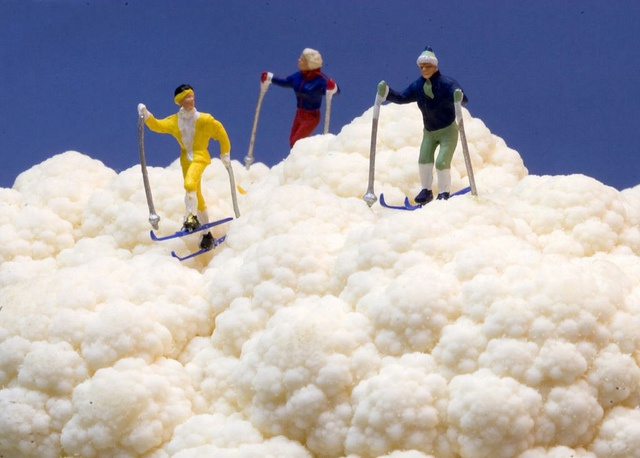Describe the objects in this image and their specific colors. I can see people in darkblue, olive, orange, darkgray, and blue tones, people in darkblue, black, gray, darkgray, and navy tones, people in darkblue, navy, maroon, and darkgray tones, and skis in darkblue, blue, and darkgray tones in this image. 